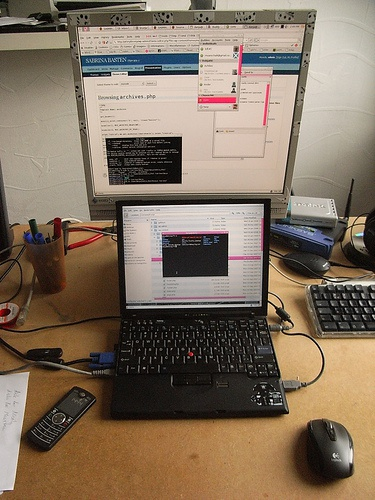Describe the objects in this image and their specific colors. I can see tv in black, lightgray, tan, and gray tones, laptop in black, darkgray, lightgray, and gray tones, keyboard in black, gray, and darkgray tones, keyboard in black, gray, and tan tones, and mouse in black, gray, and darkgray tones in this image. 